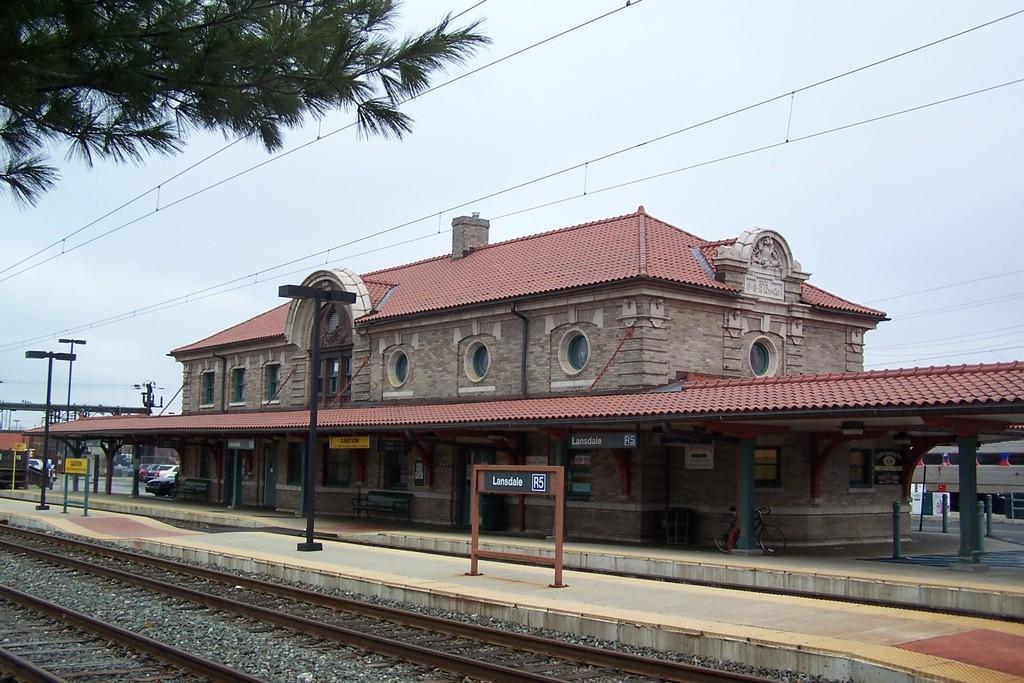Could you give a brief overview of what you see in this image? In this image, there is a railway station. There are poles on the platform. There are tracks in the bottom left of the image. There are branches in the top left of the image. In the background of the image, there is a sky. 